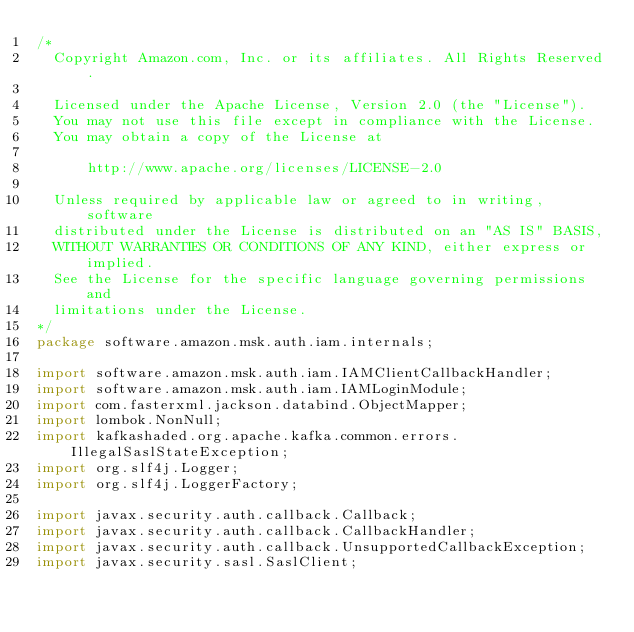Convert code to text. <code><loc_0><loc_0><loc_500><loc_500><_Java_>/*
  Copyright Amazon.com, Inc. or its affiliates. All Rights Reserved.

  Licensed under the Apache License, Version 2.0 (the "License").
  You may not use this file except in compliance with the License.
  You may obtain a copy of the License at

      http://www.apache.org/licenses/LICENSE-2.0

  Unless required by applicable law or agreed to in writing, software
  distributed under the License is distributed on an "AS IS" BASIS,
  WITHOUT WARRANTIES OR CONDITIONS OF ANY KIND, either express or implied.
  See the License for the specific language governing permissions and
  limitations under the License.
*/
package software.amazon.msk.auth.iam.internals;

import software.amazon.msk.auth.iam.IAMClientCallbackHandler;
import software.amazon.msk.auth.iam.IAMLoginModule;
import com.fasterxml.jackson.databind.ObjectMapper;
import lombok.NonNull;
import kafkashaded.org.apache.kafka.common.errors.IllegalSaslStateException;
import org.slf4j.Logger;
import org.slf4j.LoggerFactory;

import javax.security.auth.callback.Callback;
import javax.security.auth.callback.CallbackHandler;
import javax.security.auth.callback.UnsupportedCallbackException;
import javax.security.sasl.SaslClient;</code> 